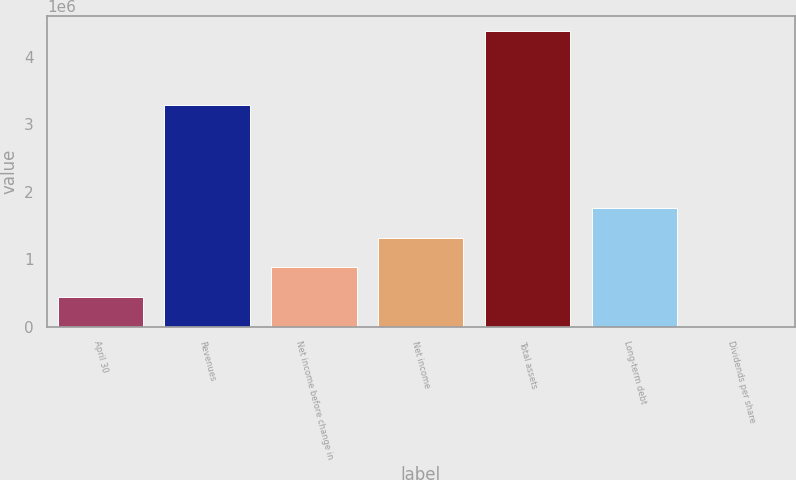Convert chart to OTSL. <chart><loc_0><loc_0><loc_500><loc_500><bar_chart><fcel>April 30<fcel>Revenues<fcel>Net income before change in<fcel>Net income<fcel>Total assets<fcel>Long-term debt<fcel>Dividends per share<nl><fcel>438465<fcel>3.2857e+06<fcel>876929<fcel>1.31539e+06<fcel>4.38464e+06<fcel>1.75386e+06<fcel>0.63<nl></chart> 